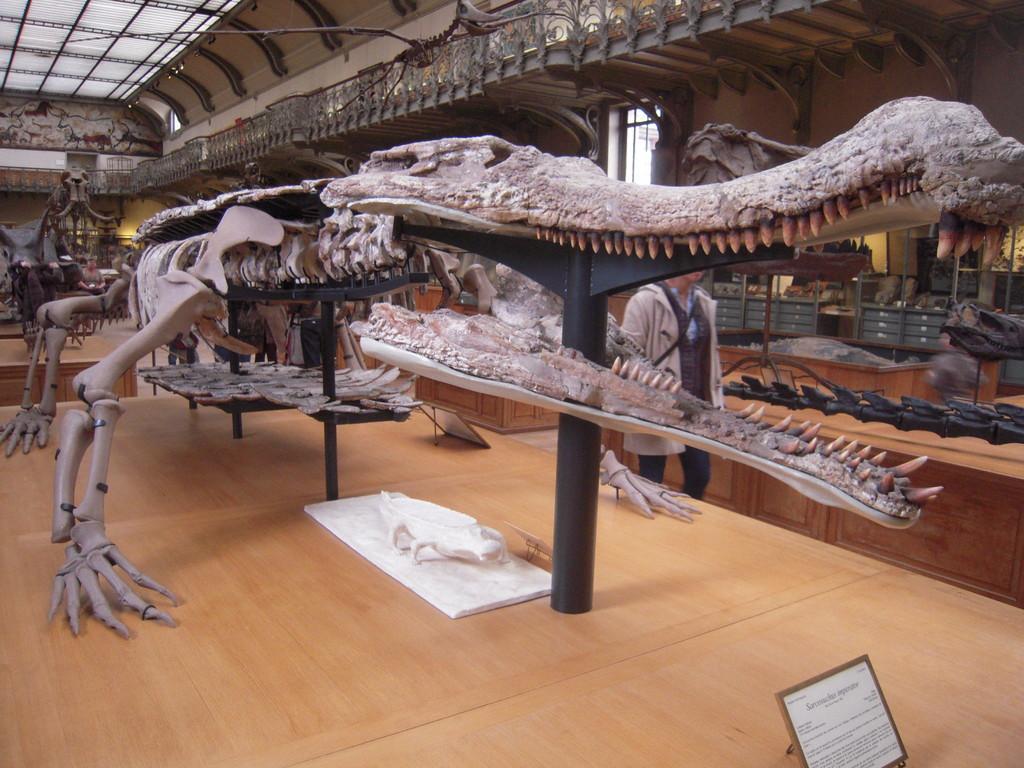Please provide a concise description of this image. This is a museum. In this picture we can see a few skeletons of an animal on a wooden surface. There is a board and a text on this board. on a wooden surface. We can a person. 